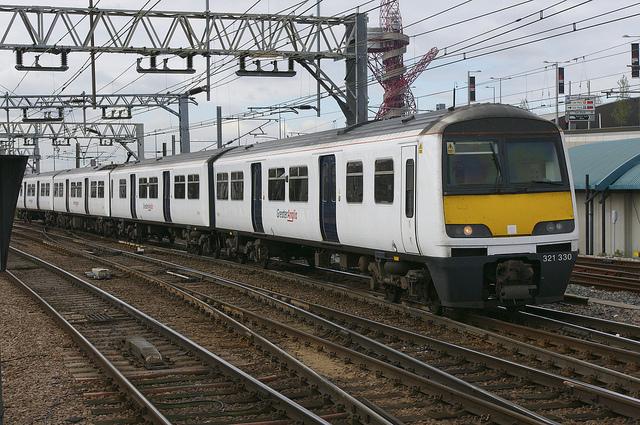How many tracks are there?
Give a very brief answer. 5. Why is the train at platform 5?
Write a very short answer. Waiting for passengers. Is it inside or outside?
Write a very short answer. Outside. What colors are the train?
Write a very short answer. White and yellow. Is the picture in color?
Keep it brief. Yes. What color is the train?
Concise answer only. White. What is above the train?
Keep it brief. Wires. Is there a pink stripe on the train?
Write a very short answer. No. What is the train number?
Concise answer only. 321 330. Where is the train going?
Write a very short answer. City. Are the train tracks rusty?
Write a very short answer. Yes. What color scheme is the photo in?
Answer briefly. White. How many trucks of rail are there?
Be succinct. 3. What color is this train?
Be succinct. White. How many trains are there?
Quick response, please. 1. How many windows are there?
Keep it brief. 24. Is this train in motion?
Short answer required. Yes. How would you describe the weather conditions?
Answer briefly. Cloudy. 